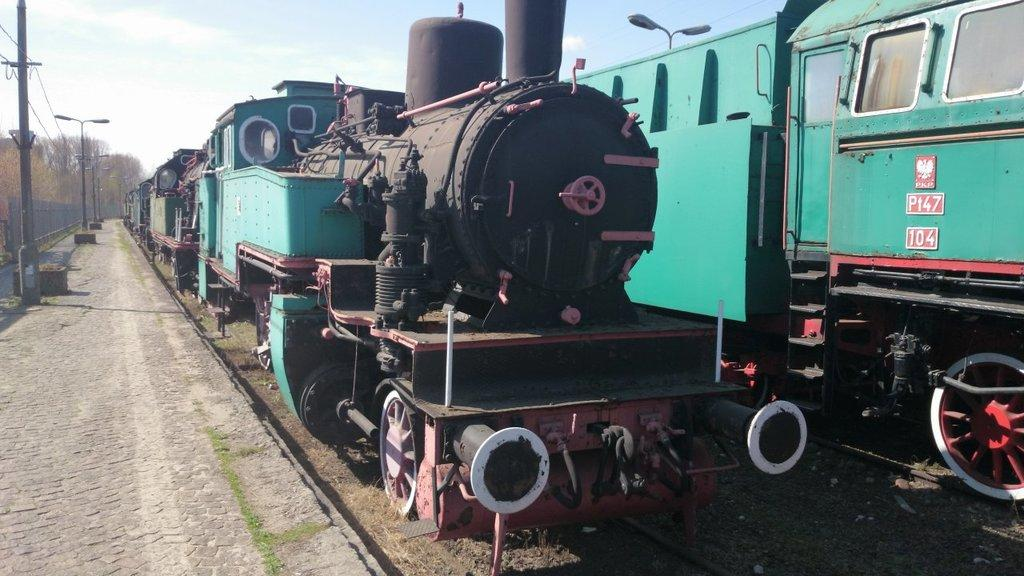What can be seen on the track in the foreground of the image? There are two trains on the track in the foreground of the image. What is located on the left side of the image? There is a path on the left side of the image. What can be found on the path? There are poles on the path. What is visible in the background of the image? There are trees, fencing, and the sky visible in the background of the image. Can you see any cobwebs hanging from the poles on the path in the image? There is no mention of cobwebs in the provided facts, so we cannot determine if any are present in the image. What is the season depicted in the image? The provided facts do not mention any seasonal details, so we cannot determine the season from the image. 